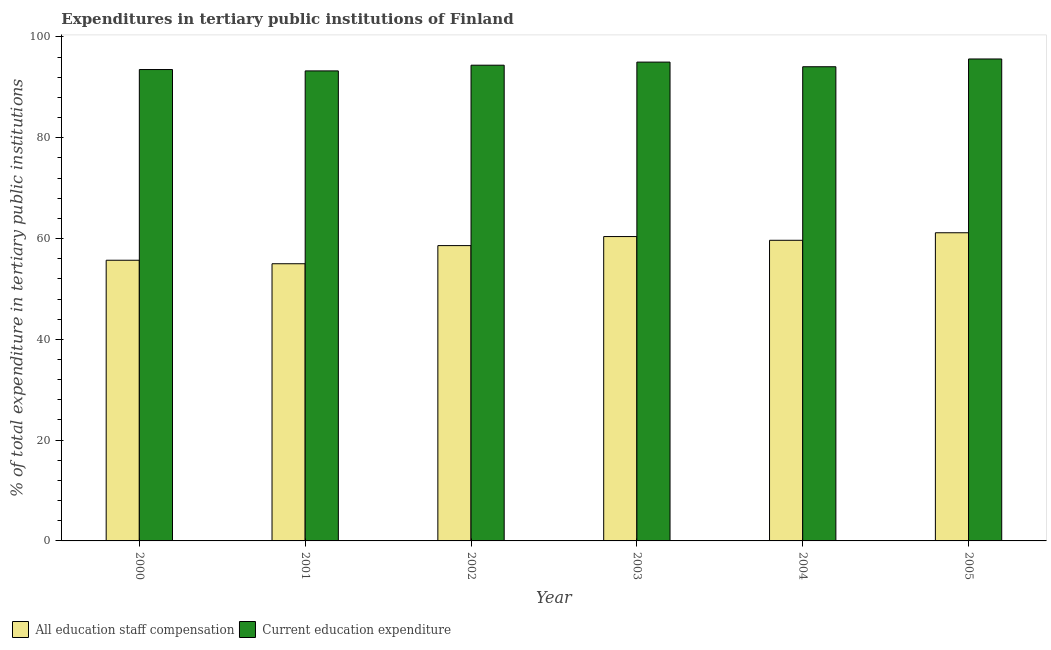How many groups of bars are there?
Provide a succinct answer. 6. Are the number of bars on each tick of the X-axis equal?
Provide a succinct answer. Yes. In how many cases, is the number of bars for a given year not equal to the number of legend labels?
Offer a very short reply. 0. What is the expenditure in education in 2005?
Give a very brief answer. 95.64. Across all years, what is the maximum expenditure in education?
Make the answer very short. 95.64. Across all years, what is the minimum expenditure in staff compensation?
Make the answer very short. 55. In which year was the expenditure in education maximum?
Your answer should be very brief. 2005. What is the total expenditure in staff compensation in the graph?
Provide a succinct answer. 350.5. What is the difference between the expenditure in staff compensation in 2001 and that in 2005?
Give a very brief answer. -6.15. What is the difference between the expenditure in staff compensation in 2000 and the expenditure in education in 2002?
Offer a terse response. -2.9. What is the average expenditure in education per year?
Your response must be concise. 94.33. In how many years, is the expenditure in education greater than 60 %?
Ensure brevity in your answer.  6. What is the ratio of the expenditure in staff compensation in 2002 to that in 2005?
Offer a very short reply. 0.96. What is the difference between the highest and the second highest expenditure in staff compensation?
Keep it short and to the point. 0.75. What is the difference between the highest and the lowest expenditure in education?
Keep it short and to the point. 2.37. In how many years, is the expenditure in education greater than the average expenditure in education taken over all years?
Ensure brevity in your answer.  3. Is the sum of the expenditure in staff compensation in 2000 and 2002 greater than the maximum expenditure in education across all years?
Provide a succinct answer. Yes. What does the 1st bar from the left in 2005 represents?
Offer a very short reply. All education staff compensation. What does the 2nd bar from the right in 2005 represents?
Offer a very short reply. All education staff compensation. How many bars are there?
Your answer should be compact. 12. Are all the bars in the graph horizontal?
Provide a short and direct response. No. What is the difference between two consecutive major ticks on the Y-axis?
Your answer should be compact. 20. Are the values on the major ticks of Y-axis written in scientific E-notation?
Keep it short and to the point. No. Does the graph contain any zero values?
Provide a short and direct response. No. How are the legend labels stacked?
Provide a short and direct response. Horizontal. What is the title of the graph?
Provide a short and direct response. Expenditures in tertiary public institutions of Finland. What is the label or title of the X-axis?
Provide a short and direct response. Year. What is the label or title of the Y-axis?
Offer a terse response. % of total expenditure in tertiary public institutions. What is the % of total expenditure in tertiary public institutions of All education staff compensation in 2000?
Ensure brevity in your answer.  55.7. What is the % of total expenditure in tertiary public institutions in Current education expenditure in 2000?
Offer a terse response. 93.54. What is the % of total expenditure in tertiary public institutions in All education staff compensation in 2001?
Provide a succinct answer. 55. What is the % of total expenditure in tertiary public institutions of Current education expenditure in 2001?
Give a very brief answer. 93.27. What is the % of total expenditure in tertiary public institutions in All education staff compensation in 2002?
Offer a terse response. 58.6. What is the % of total expenditure in tertiary public institutions in Current education expenditure in 2002?
Ensure brevity in your answer.  94.4. What is the % of total expenditure in tertiary public institutions in All education staff compensation in 2003?
Offer a terse response. 60.4. What is the % of total expenditure in tertiary public institutions in Current education expenditure in 2003?
Provide a short and direct response. 95.01. What is the % of total expenditure in tertiary public institutions in All education staff compensation in 2004?
Ensure brevity in your answer.  59.66. What is the % of total expenditure in tertiary public institutions in Current education expenditure in 2004?
Your response must be concise. 94.09. What is the % of total expenditure in tertiary public institutions of All education staff compensation in 2005?
Give a very brief answer. 61.15. What is the % of total expenditure in tertiary public institutions of Current education expenditure in 2005?
Keep it short and to the point. 95.64. Across all years, what is the maximum % of total expenditure in tertiary public institutions in All education staff compensation?
Ensure brevity in your answer.  61.15. Across all years, what is the maximum % of total expenditure in tertiary public institutions of Current education expenditure?
Make the answer very short. 95.64. Across all years, what is the minimum % of total expenditure in tertiary public institutions of All education staff compensation?
Your response must be concise. 55. Across all years, what is the minimum % of total expenditure in tertiary public institutions of Current education expenditure?
Offer a very short reply. 93.27. What is the total % of total expenditure in tertiary public institutions in All education staff compensation in the graph?
Provide a short and direct response. 350.5. What is the total % of total expenditure in tertiary public institutions in Current education expenditure in the graph?
Your answer should be compact. 565.95. What is the difference between the % of total expenditure in tertiary public institutions of All education staff compensation in 2000 and that in 2001?
Provide a short and direct response. 0.7. What is the difference between the % of total expenditure in tertiary public institutions of Current education expenditure in 2000 and that in 2001?
Give a very brief answer. 0.27. What is the difference between the % of total expenditure in tertiary public institutions of All education staff compensation in 2000 and that in 2002?
Make the answer very short. -2.9. What is the difference between the % of total expenditure in tertiary public institutions of Current education expenditure in 2000 and that in 2002?
Offer a very short reply. -0.86. What is the difference between the % of total expenditure in tertiary public institutions in All education staff compensation in 2000 and that in 2003?
Give a very brief answer. -4.7. What is the difference between the % of total expenditure in tertiary public institutions of Current education expenditure in 2000 and that in 2003?
Make the answer very short. -1.47. What is the difference between the % of total expenditure in tertiary public institutions in All education staff compensation in 2000 and that in 2004?
Your answer should be very brief. -3.96. What is the difference between the % of total expenditure in tertiary public institutions of Current education expenditure in 2000 and that in 2004?
Provide a short and direct response. -0.56. What is the difference between the % of total expenditure in tertiary public institutions of All education staff compensation in 2000 and that in 2005?
Offer a terse response. -5.45. What is the difference between the % of total expenditure in tertiary public institutions of Current education expenditure in 2000 and that in 2005?
Offer a very short reply. -2.1. What is the difference between the % of total expenditure in tertiary public institutions in All education staff compensation in 2001 and that in 2002?
Keep it short and to the point. -3.6. What is the difference between the % of total expenditure in tertiary public institutions of Current education expenditure in 2001 and that in 2002?
Give a very brief answer. -1.13. What is the difference between the % of total expenditure in tertiary public institutions of All education staff compensation in 2001 and that in 2003?
Make the answer very short. -5.4. What is the difference between the % of total expenditure in tertiary public institutions in Current education expenditure in 2001 and that in 2003?
Offer a terse response. -1.75. What is the difference between the % of total expenditure in tertiary public institutions of All education staff compensation in 2001 and that in 2004?
Keep it short and to the point. -4.66. What is the difference between the % of total expenditure in tertiary public institutions of Current education expenditure in 2001 and that in 2004?
Your answer should be compact. -0.83. What is the difference between the % of total expenditure in tertiary public institutions of All education staff compensation in 2001 and that in 2005?
Offer a very short reply. -6.15. What is the difference between the % of total expenditure in tertiary public institutions of Current education expenditure in 2001 and that in 2005?
Offer a terse response. -2.37. What is the difference between the % of total expenditure in tertiary public institutions in All education staff compensation in 2002 and that in 2003?
Provide a succinct answer. -1.8. What is the difference between the % of total expenditure in tertiary public institutions of Current education expenditure in 2002 and that in 2003?
Provide a short and direct response. -0.61. What is the difference between the % of total expenditure in tertiary public institutions of All education staff compensation in 2002 and that in 2004?
Provide a succinct answer. -1.06. What is the difference between the % of total expenditure in tertiary public institutions of Current education expenditure in 2002 and that in 2004?
Make the answer very short. 0.31. What is the difference between the % of total expenditure in tertiary public institutions of All education staff compensation in 2002 and that in 2005?
Offer a terse response. -2.55. What is the difference between the % of total expenditure in tertiary public institutions of Current education expenditure in 2002 and that in 2005?
Provide a succinct answer. -1.24. What is the difference between the % of total expenditure in tertiary public institutions in All education staff compensation in 2003 and that in 2004?
Your answer should be compact. 0.74. What is the difference between the % of total expenditure in tertiary public institutions in Current education expenditure in 2003 and that in 2004?
Provide a short and direct response. 0.92. What is the difference between the % of total expenditure in tertiary public institutions of All education staff compensation in 2003 and that in 2005?
Provide a short and direct response. -0.75. What is the difference between the % of total expenditure in tertiary public institutions of Current education expenditure in 2003 and that in 2005?
Your answer should be very brief. -0.62. What is the difference between the % of total expenditure in tertiary public institutions in All education staff compensation in 2004 and that in 2005?
Your answer should be very brief. -1.49. What is the difference between the % of total expenditure in tertiary public institutions in Current education expenditure in 2004 and that in 2005?
Your answer should be very brief. -1.54. What is the difference between the % of total expenditure in tertiary public institutions of All education staff compensation in 2000 and the % of total expenditure in tertiary public institutions of Current education expenditure in 2001?
Offer a terse response. -37.57. What is the difference between the % of total expenditure in tertiary public institutions of All education staff compensation in 2000 and the % of total expenditure in tertiary public institutions of Current education expenditure in 2002?
Ensure brevity in your answer.  -38.7. What is the difference between the % of total expenditure in tertiary public institutions in All education staff compensation in 2000 and the % of total expenditure in tertiary public institutions in Current education expenditure in 2003?
Offer a terse response. -39.32. What is the difference between the % of total expenditure in tertiary public institutions in All education staff compensation in 2000 and the % of total expenditure in tertiary public institutions in Current education expenditure in 2004?
Provide a short and direct response. -38.4. What is the difference between the % of total expenditure in tertiary public institutions of All education staff compensation in 2000 and the % of total expenditure in tertiary public institutions of Current education expenditure in 2005?
Provide a short and direct response. -39.94. What is the difference between the % of total expenditure in tertiary public institutions in All education staff compensation in 2001 and the % of total expenditure in tertiary public institutions in Current education expenditure in 2002?
Your response must be concise. -39.4. What is the difference between the % of total expenditure in tertiary public institutions of All education staff compensation in 2001 and the % of total expenditure in tertiary public institutions of Current education expenditure in 2003?
Your response must be concise. -40.01. What is the difference between the % of total expenditure in tertiary public institutions in All education staff compensation in 2001 and the % of total expenditure in tertiary public institutions in Current education expenditure in 2004?
Offer a very short reply. -39.09. What is the difference between the % of total expenditure in tertiary public institutions of All education staff compensation in 2001 and the % of total expenditure in tertiary public institutions of Current education expenditure in 2005?
Your response must be concise. -40.63. What is the difference between the % of total expenditure in tertiary public institutions of All education staff compensation in 2002 and the % of total expenditure in tertiary public institutions of Current education expenditure in 2003?
Your response must be concise. -36.41. What is the difference between the % of total expenditure in tertiary public institutions of All education staff compensation in 2002 and the % of total expenditure in tertiary public institutions of Current education expenditure in 2004?
Provide a short and direct response. -35.49. What is the difference between the % of total expenditure in tertiary public institutions in All education staff compensation in 2002 and the % of total expenditure in tertiary public institutions in Current education expenditure in 2005?
Your answer should be compact. -37.03. What is the difference between the % of total expenditure in tertiary public institutions in All education staff compensation in 2003 and the % of total expenditure in tertiary public institutions in Current education expenditure in 2004?
Ensure brevity in your answer.  -33.7. What is the difference between the % of total expenditure in tertiary public institutions of All education staff compensation in 2003 and the % of total expenditure in tertiary public institutions of Current education expenditure in 2005?
Make the answer very short. -35.24. What is the difference between the % of total expenditure in tertiary public institutions of All education staff compensation in 2004 and the % of total expenditure in tertiary public institutions of Current education expenditure in 2005?
Keep it short and to the point. -35.98. What is the average % of total expenditure in tertiary public institutions of All education staff compensation per year?
Your response must be concise. 58.42. What is the average % of total expenditure in tertiary public institutions in Current education expenditure per year?
Ensure brevity in your answer.  94.33. In the year 2000, what is the difference between the % of total expenditure in tertiary public institutions of All education staff compensation and % of total expenditure in tertiary public institutions of Current education expenditure?
Provide a short and direct response. -37.84. In the year 2001, what is the difference between the % of total expenditure in tertiary public institutions in All education staff compensation and % of total expenditure in tertiary public institutions in Current education expenditure?
Provide a succinct answer. -38.27. In the year 2002, what is the difference between the % of total expenditure in tertiary public institutions of All education staff compensation and % of total expenditure in tertiary public institutions of Current education expenditure?
Provide a succinct answer. -35.8. In the year 2003, what is the difference between the % of total expenditure in tertiary public institutions in All education staff compensation and % of total expenditure in tertiary public institutions in Current education expenditure?
Your answer should be very brief. -34.62. In the year 2004, what is the difference between the % of total expenditure in tertiary public institutions of All education staff compensation and % of total expenditure in tertiary public institutions of Current education expenditure?
Provide a short and direct response. -34.44. In the year 2005, what is the difference between the % of total expenditure in tertiary public institutions in All education staff compensation and % of total expenditure in tertiary public institutions in Current education expenditure?
Provide a succinct answer. -34.49. What is the ratio of the % of total expenditure in tertiary public institutions of All education staff compensation in 2000 to that in 2001?
Provide a short and direct response. 1.01. What is the ratio of the % of total expenditure in tertiary public institutions in All education staff compensation in 2000 to that in 2002?
Keep it short and to the point. 0.95. What is the ratio of the % of total expenditure in tertiary public institutions of Current education expenditure in 2000 to that in 2002?
Make the answer very short. 0.99. What is the ratio of the % of total expenditure in tertiary public institutions of All education staff compensation in 2000 to that in 2003?
Your answer should be compact. 0.92. What is the ratio of the % of total expenditure in tertiary public institutions in Current education expenditure in 2000 to that in 2003?
Make the answer very short. 0.98. What is the ratio of the % of total expenditure in tertiary public institutions in All education staff compensation in 2000 to that in 2004?
Provide a short and direct response. 0.93. What is the ratio of the % of total expenditure in tertiary public institutions of All education staff compensation in 2000 to that in 2005?
Offer a terse response. 0.91. What is the ratio of the % of total expenditure in tertiary public institutions in Current education expenditure in 2000 to that in 2005?
Keep it short and to the point. 0.98. What is the ratio of the % of total expenditure in tertiary public institutions in All education staff compensation in 2001 to that in 2002?
Ensure brevity in your answer.  0.94. What is the ratio of the % of total expenditure in tertiary public institutions of Current education expenditure in 2001 to that in 2002?
Keep it short and to the point. 0.99. What is the ratio of the % of total expenditure in tertiary public institutions of All education staff compensation in 2001 to that in 2003?
Your answer should be compact. 0.91. What is the ratio of the % of total expenditure in tertiary public institutions of Current education expenditure in 2001 to that in 2003?
Provide a succinct answer. 0.98. What is the ratio of the % of total expenditure in tertiary public institutions in All education staff compensation in 2001 to that in 2004?
Provide a short and direct response. 0.92. What is the ratio of the % of total expenditure in tertiary public institutions of All education staff compensation in 2001 to that in 2005?
Provide a succinct answer. 0.9. What is the ratio of the % of total expenditure in tertiary public institutions in Current education expenditure in 2001 to that in 2005?
Ensure brevity in your answer.  0.98. What is the ratio of the % of total expenditure in tertiary public institutions of All education staff compensation in 2002 to that in 2003?
Ensure brevity in your answer.  0.97. What is the ratio of the % of total expenditure in tertiary public institutions in All education staff compensation in 2002 to that in 2004?
Offer a terse response. 0.98. What is the ratio of the % of total expenditure in tertiary public institutions of Current education expenditure in 2002 to that in 2004?
Provide a short and direct response. 1. What is the ratio of the % of total expenditure in tertiary public institutions of All education staff compensation in 2002 to that in 2005?
Provide a succinct answer. 0.96. What is the ratio of the % of total expenditure in tertiary public institutions in Current education expenditure in 2002 to that in 2005?
Ensure brevity in your answer.  0.99. What is the ratio of the % of total expenditure in tertiary public institutions in All education staff compensation in 2003 to that in 2004?
Your response must be concise. 1.01. What is the ratio of the % of total expenditure in tertiary public institutions in Current education expenditure in 2003 to that in 2004?
Offer a terse response. 1.01. What is the ratio of the % of total expenditure in tertiary public institutions of All education staff compensation in 2003 to that in 2005?
Offer a terse response. 0.99. What is the ratio of the % of total expenditure in tertiary public institutions in All education staff compensation in 2004 to that in 2005?
Your answer should be very brief. 0.98. What is the ratio of the % of total expenditure in tertiary public institutions in Current education expenditure in 2004 to that in 2005?
Make the answer very short. 0.98. What is the difference between the highest and the second highest % of total expenditure in tertiary public institutions in All education staff compensation?
Your answer should be very brief. 0.75. What is the difference between the highest and the second highest % of total expenditure in tertiary public institutions in Current education expenditure?
Provide a short and direct response. 0.62. What is the difference between the highest and the lowest % of total expenditure in tertiary public institutions of All education staff compensation?
Keep it short and to the point. 6.15. What is the difference between the highest and the lowest % of total expenditure in tertiary public institutions in Current education expenditure?
Your answer should be very brief. 2.37. 